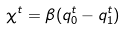<formula> <loc_0><loc_0><loc_500><loc_500>\chi ^ { t } = \beta ( q _ { 0 } ^ { t } - q _ { 1 } ^ { t } )</formula> 